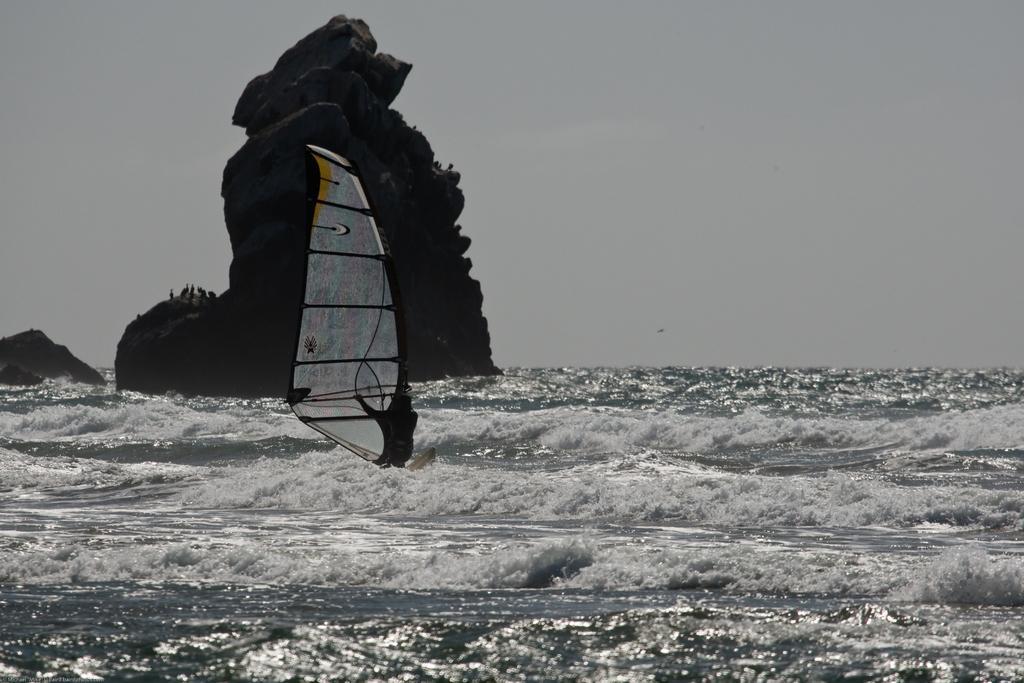Please provide a concise description of this image. In the image in the center we can see water,hill and sail. In the background we can see the sky. 